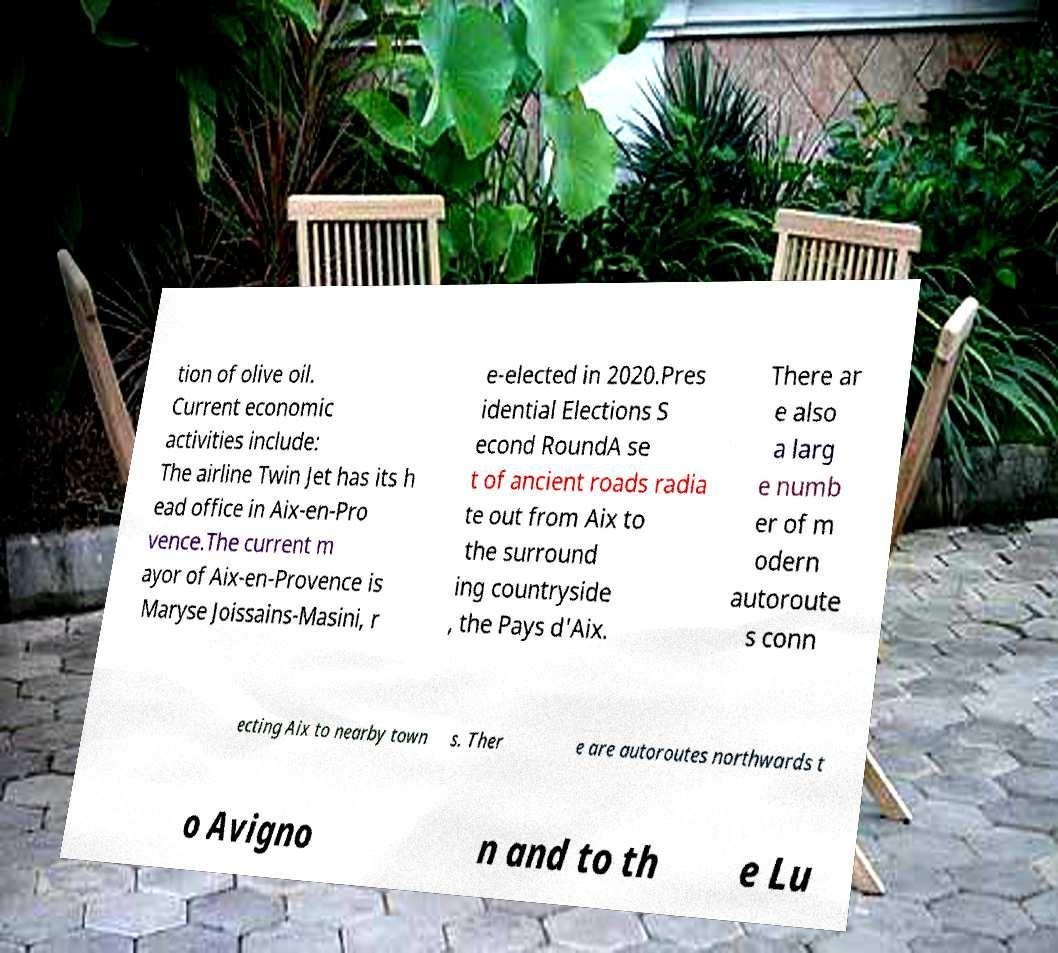Can you read and provide the text displayed in the image?This photo seems to have some interesting text. Can you extract and type it out for me? tion of olive oil. Current economic activities include: The airline Twin Jet has its h ead office in Aix-en-Pro vence.The current m ayor of Aix-en-Provence is Maryse Joissains-Masini, r e-elected in 2020.Pres idential Elections S econd RoundA se t of ancient roads radia te out from Aix to the surround ing countryside , the Pays d'Aix. There ar e also a larg e numb er of m odern autoroute s conn ecting Aix to nearby town s. Ther e are autoroutes northwards t o Avigno n and to th e Lu 